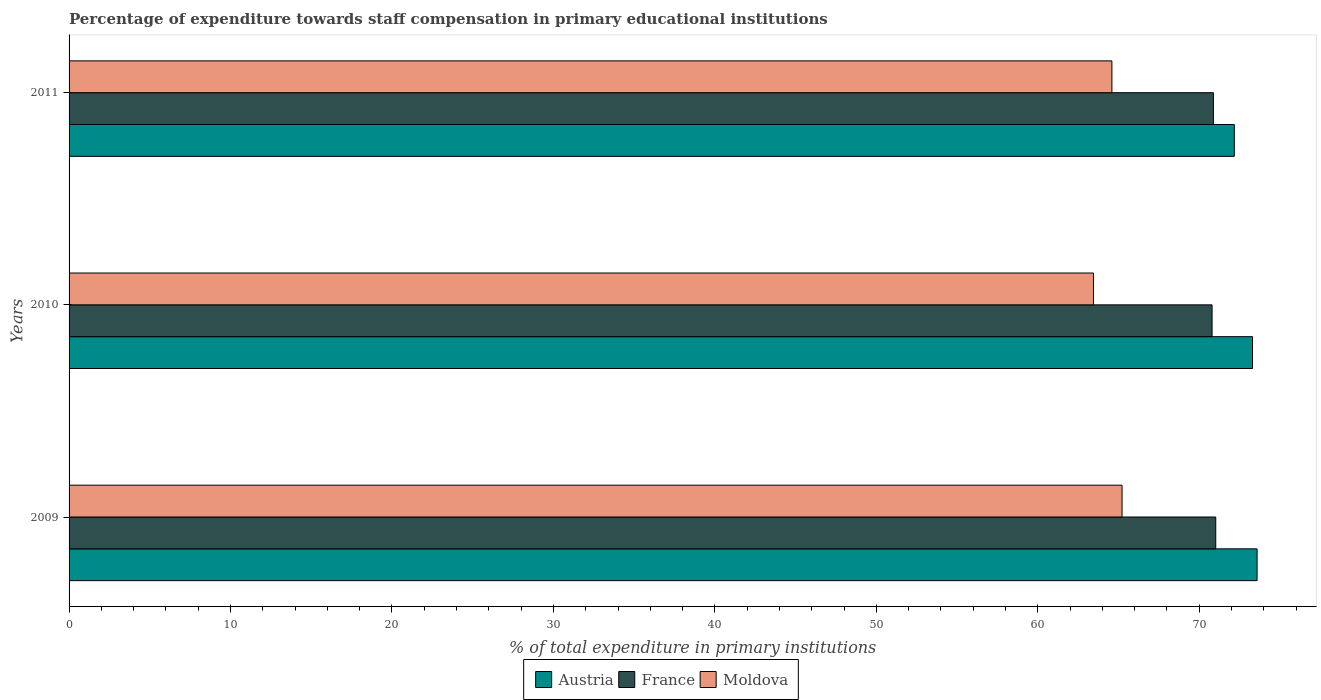How many different coloured bars are there?
Provide a short and direct response. 3. Are the number of bars on each tick of the Y-axis equal?
Give a very brief answer. Yes. How many bars are there on the 3rd tick from the top?
Your answer should be very brief. 3. What is the label of the 3rd group of bars from the top?
Your answer should be very brief. 2009. In how many cases, is the number of bars for a given year not equal to the number of legend labels?
Provide a short and direct response. 0. What is the percentage of expenditure towards staff compensation in Moldova in 2009?
Ensure brevity in your answer.  65.22. Across all years, what is the maximum percentage of expenditure towards staff compensation in Austria?
Your answer should be very brief. 73.58. Across all years, what is the minimum percentage of expenditure towards staff compensation in Moldova?
Your answer should be very brief. 63.45. In which year was the percentage of expenditure towards staff compensation in Moldova maximum?
Provide a short and direct response. 2009. In which year was the percentage of expenditure towards staff compensation in Austria minimum?
Your response must be concise. 2011. What is the total percentage of expenditure towards staff compensation in Moldova in the graph?
Offer a terse response. 193.25. What is the difference between the percentage of expenditure towards staff compensation in France in 2009 and that in 2010?
Offer a terse response. 0.23. What is the difference between the percentage of expenditure towards staff compensation in France in 2010 and the percentage of expenditure towards staff compensation in Austria in 2011?
Your answer should be compact. -1.38. What is the average percentage of expenditure towards staff compensation in France per year?
Your response must be concise. 70.9. In the year 2009, what is the difference between the percentage of expenditure towards staff compensation in France and percentage of expenditure towards staff compensation in Austria?
Ensure brevity in your answer.  -2.56. What is the ratio of the percentage of expenditure towards staff compensation in Austria in 2009 to that in 2011?
Offer a very short reply. 1.02. Is the percentage of expenditure towards staff compensation in France in 2009 less than that in 2010?
Offer a terse response. No. Is the difference between the percentage of expenditure towards staff compensation in France in 2010 and 2011 greater than the difference between the percentage of expenditure towards staff compensation in Austria in 2010 and 2011?
Your answer should be compact. No. What is the difference between the highest and the second highest percentage of expenditure towards staff compensation in Moldova?
Your answer should be compact. 0.63. What is the difference between the highest and the lowest percentage of expenditure towards staff compensation in France?
Your response must be concise. 0.23. Is the sum of the percentage of expenditure towards staff compensation in Moldova in 2009 and 2011 greater than the maximum percentage of expenditure towards staff compensation in Austria across all years?
Offer a very short reply. Yes. What does the 3rd bar from the bottom in 2010 represents?
Give a very brief answer. Moldova. Is it the case that in every year, the sum of the percentage of expenditure towards staff compensation in Moldova and percentage of expenditure towards staff compensation in France is greater than the percentage of expenditure towards staff compensation in Austria?
Offer a terse response. Yes. How many bars are there?
Provide a short and direct response. 9. Are all the bars in the graph horizontal?
Make the answer very short. Yes. How many years are there in the graph?
Your answer should be very brief. 3. Does the graph contain any zero values?
Make the answer very short. No. What is the title of the graph?
Your answer should be compact. Percentage of expenditure towards staff compensation in primary educational institutions. What is the label or title of the X-axis?
Your answer should be compact. % of total expenditure in primary institutions. What is the % of total expenditure in primary institutions of Austria in 2009?
Give a very brief answer. 73.58. What is the % of total expenditure in primary institutions in France in 2009?
Keep it short and to the point. 71.02. What is the % of total expenditure in primary institutions in Moldova in 2009?
Your answer should be compact. 65.22. What is the % of total expenditure in primary institutions of Austria in 2010?
Your answer should be very brief. 73.3. What is the % of total expenditure in primary institutions in France in 2010?
Give a very brief answer. 70.79. What is the % of total expenditure in primary institutions of Moldova in 2010?
Offer a terse response. 63.45. What is the % of total expenditure in primary institutions of Austria in 2011?
Offer a very short reply. 72.17. What is the % of total expenditure in primary institutions in France in 2011?
Your answer should be very brief. 70.88. What is the % of total expenditure in primary institutions in Moldova in 2011?
Keep it short and to the point. 64.59. Across all years, what is the maximum % of total expenditure in primary institutions of Austria?
Your response must be concise. 73.58. Across all years, what is the maximum % of total expenditure in primary institutions of France?
Provide a short and direct response. 71.02. Across all years, what is the maximum % of total expenditure in primary institutions of Moldova?
Ensure brevity in your answer.  65.22. Across all years, what is the minimum % of total expenditure in primary institutions in Austria?
Make the answer very short. 72.17. Across all years, what is the minimum % of total expenditure in primary institutions in France?
Offer a very short reply. 70.79. Across all years, what is the minimum % of total expenditure in primary institutions in Moldova?
Give a very brief answer. 63.45. What is the total % of total expenditure in primary institutions in Austria in the graph?
Make the answer very short. 219.05. What is the total % of total expenditure in primary institutions in France in the graph?
Your answer should be compact. 212.69. What is the total % of total expenditure in primary institutions of Moldova in the graph?
Offer a very short reply. 193.25. What is the difference between the % of total expenditure in primary institutions of Austria in 2009 and that in 2010?
Ensure brevity in your answer.  0.28. What is the difference between the % of total expenditure in primary institutions of France in 2009 and that in 2010?
Make the answer very short. 0.23. What is the difference between the % of total expenditure in primary institutions in Moldova in 2009 and that in 2010?
Provide a succinct answer. 1.77. What is the difference between the % of total expenditure in primary institutions in Austria in 2009 and that in 2011?
Ensure brevity in your answer.  1.41. What is the difference between the % of total expenditure in primary institutions in France in 2009 and that in 2011?
Ensure brevity in your answer.  0.15. What is the difference between the % of total expenditure in primary institutions in Moldova in 2009 and that in 2011?
Make the answer very short. 0.63. What is the difference between the % of total expenditure in primary institutions in Austria in 2010 and that in 2011?
Offer a terse response. 1.13. What is the difference between the % of total expenditure in primary institutions in France in 2010 and that in 2011?
Your response must be concise. -0.08. What is the difference between the % of total expenditure in primary institutions in Moldova in 2010 and that in 2011?
Keep it short and to the point. -1.14. What is the difference between the % of total expenditure in primary institutions of Austria in 2009 and the % of total expenditure in primary institutions of France in 2010?
Offer a terse response. 2.79. What is the difference between the % of total expenditure in primary institutions in Austria in 2009 and the % of total expenditure in primary institutions in Moldova in 2010?
Your response must be concise. 10.13. What is the difference between the % of total expenditure in primary institutions in France in 2009 and the % of total expenditure in primary institutions in Moldova in 2010?
Provide a short and direct response. 7.57. What is the difference between the % of total expenditure in primary institutions of Austria in 2009 and the % of total expenditure in primary institutions of France in 2011?
Give a very brief answer. 2.71. What is the difference between the % of total expenditure in primary institutions in Austria in 2009 and the % of total expenditure in primary institutions in Moldova in 2011?
Keep it short and to the point. 8.99. What is the difference between the % of total expenditure in primary institutions of France in 2009 and the % of total expenditure in primary institutions of Moldova in 2011?
Provide a short and direct response. 6.43. What is the difference between the % of total expenditure in primary institutions in Austria in 2010 and the % of total expenditure in primary institutions in France in 2011?
Offer a very short reply. 2.42. What is the difference between the % of total expenditure in primary institutions of Austria in 2010 and the % of total expenditure in primary institutions of Moldova in 2011?
Give a very brief answer. 8.71. What is the difference between the % of total expenditure in primary institutions of France in 2010 and the % of total expenditure in primary institutions of Moldova in 2011?
Your answer should be compact. 6.21. What is the average % of total expenditure in primary institutions of Austria per year?
Your answer should be very brief. 73.02. What is the average % of total expenditure in primary institutions of France per year?
Ensure brevity in your answer.  70.9. What is the average % of total expenditure in primary institutions of Moldova per year?
Offer a terse response. 64.42. In the year 2009, what is the difference between the % of total expenditure in primary institutions in Austria and % of total expenditure in primary institutions in France?
Offer a terse response. 2.56. In the year 2009, what is the difference between the % of total expenditure in primary institutions of Austria and % of total expenditure in primary institutions of Moldova?
Keep it short and to the point. 8.36. In the year 2009, what is the difference between the % of total expenditure in primary institutions in France and % of total expenditure in primary institutions in Moldova?
Keep it short and to the point. 5.8. In the year 2010, what is the difference between the % of total expenditure in primary institutions of Austria and % of total expenditure in primary institutions of France?
Give a very brief answer. 2.51. In the year 2010, what is the difference between the % of total expenditure in primary institutions in Austria and % of total expenditure in primary institutions in Moldova?
Offer a very short reply. 9.85. In the year 2010, what is the difference between the % of total expenditure in primary institutions in France and % of total expenditure in primary institutions in Moldova?
Ensure brevity in your answer.  7.35. In the year 2011, what is the difference between the % of total expenditure in primary institutions of Austria and % of total expenditure in primary institutions of France?
Give a very brief answer. 1.3. In the year 2011, what is the difference between the % of total expenditure in primary institutions in Austria and % of total expenditure in primary institutions in Moldova?
Ensure brevity in your answer.  7.58. In the year 2011, what is the difference between the % of total expenditure in primary institutions of France and % of total expenditure in primary institutions of Moldova?
Give a very brief answer. 6.29. What is the ratio of the % of total expenditure in primary institutions in Moldova in 2009 to that in 2010?
Ensure brevity in your answer.  1.03. What is the ratio of the % of total expenditure in primary institutions in Austria in 2009 to that in 2011?
Give a very brief answer. 1.02. What is the ratio of the % of total expenditure in primary institutions in Moldova in 2009 to that in 2011?
Your answer should be very brief. 1.01. What is the ratio of the % of total expenditure in primary institutions in Austria in 2010 to that in 2011?
Offer a very short reply. 1.02. What is the ratio of the % of total expenditure in primary institutions in France in 2010 to that in 2011?
Offer a terse response. 1. What is the ratio of the % of total expenditure in primary institutions in Moldova in 2010 to that in 2011?
Ensure brevity in your answer.  0.98. What is the difference between the highest and the second highest % of total expenditure in primary institutions of Austria?
Offer a very short reply. 0.28. What is the difference between the highest and the second highest % of total expenditure in primary institutions in France?
Your answer should be compact. 0.15. What is the difference between the highest and the second highest % of total expenditure in primary institutions of Moldova?
Ensure brevity in your answer.  0.63. What is the difference between the highest and the lowest % of total expenditure in primary institutions in Austria?
Offer a terse response. 1.41. What is the difference between the highest and the lowest % of total expenditure in primary institutions in France?
Provide a short and direct response. 0.23. What is the difference between the highest and the lowest % of total expenditure in primary institutions of Moldova?
Ensure brevity in your answer.  1.77. 